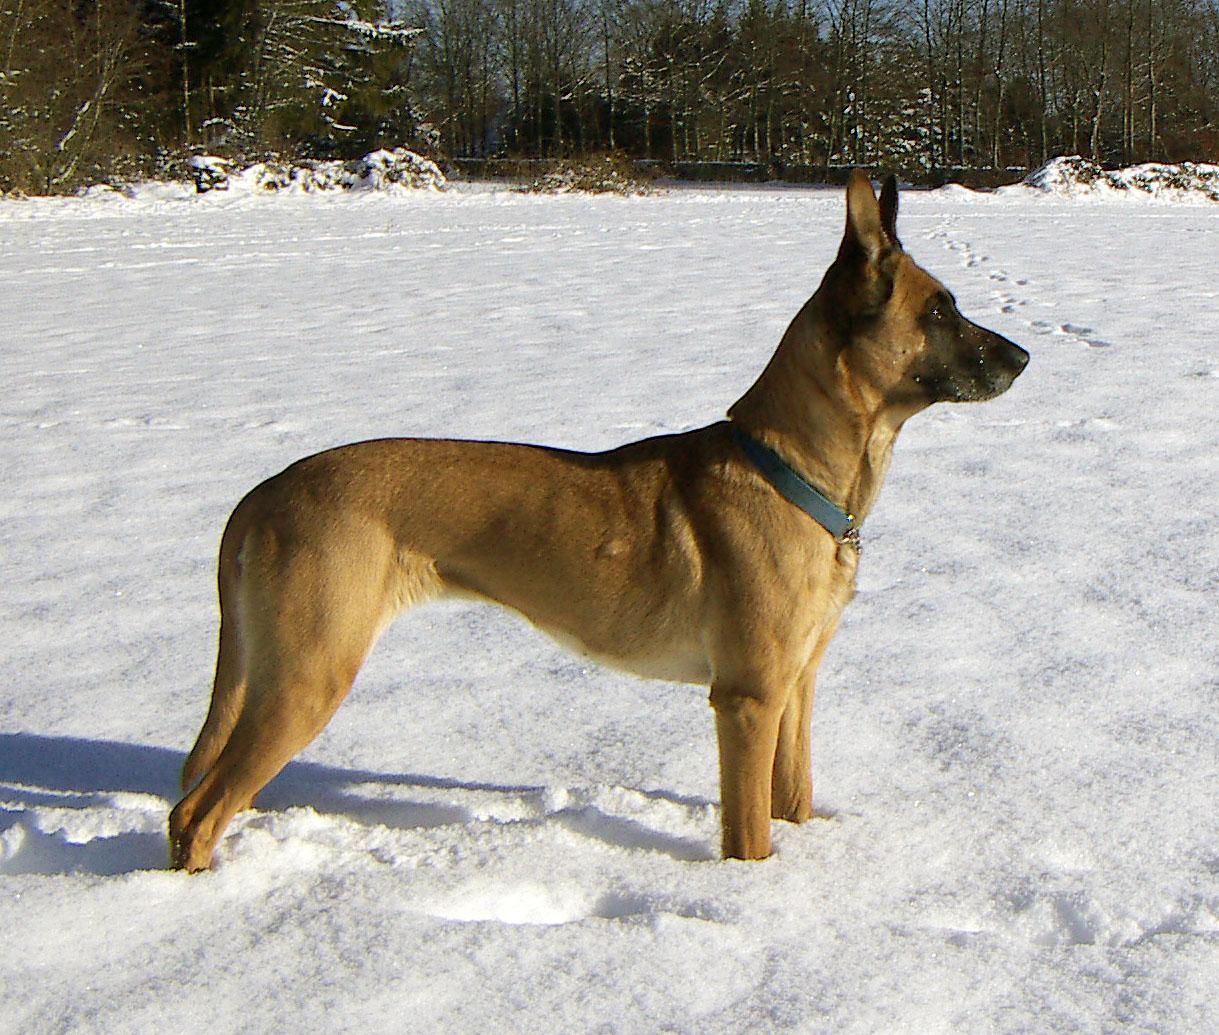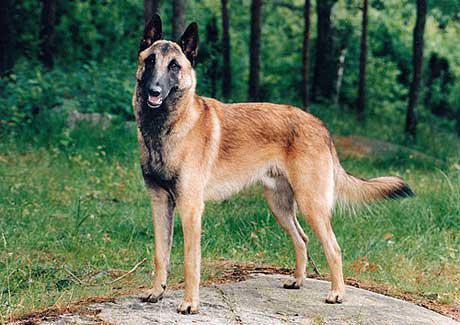The first image is the image on the left, the second image is the image on the right. Considering the images on both sides, is "There is a total of 1 German Shepard whose face and body are completely front facing." valid? Answer yes or no. No. The first image is the image on the left, the second image is the image on the right. Considering the images on both sides, is "a dog is laying in the grass with a leash on" valid? Answer yes or no. No. 